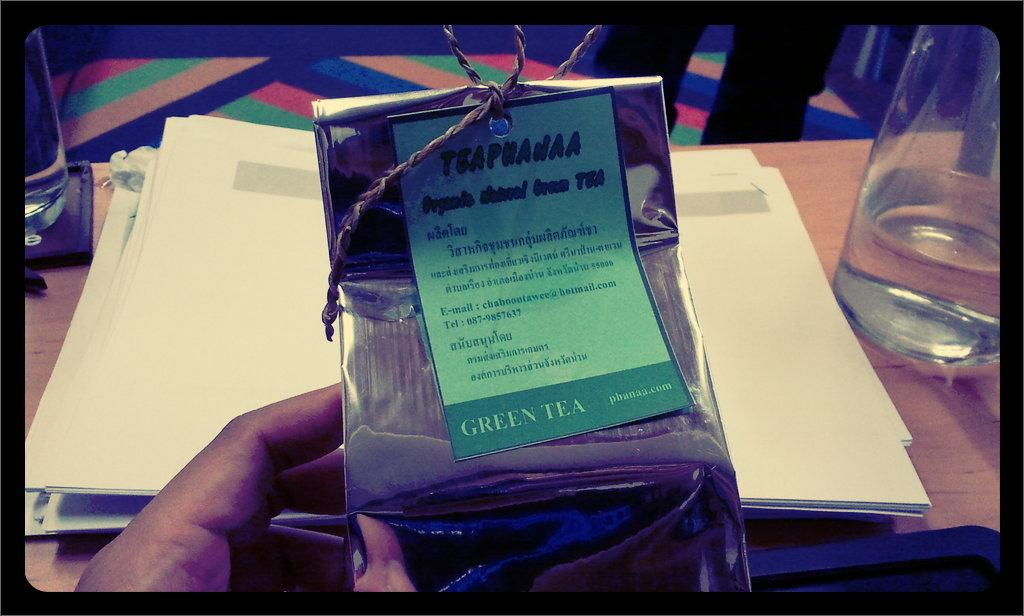<image>
Render a clear and concise summary of the photo. A hand holds something which has Green Tea written on it. 